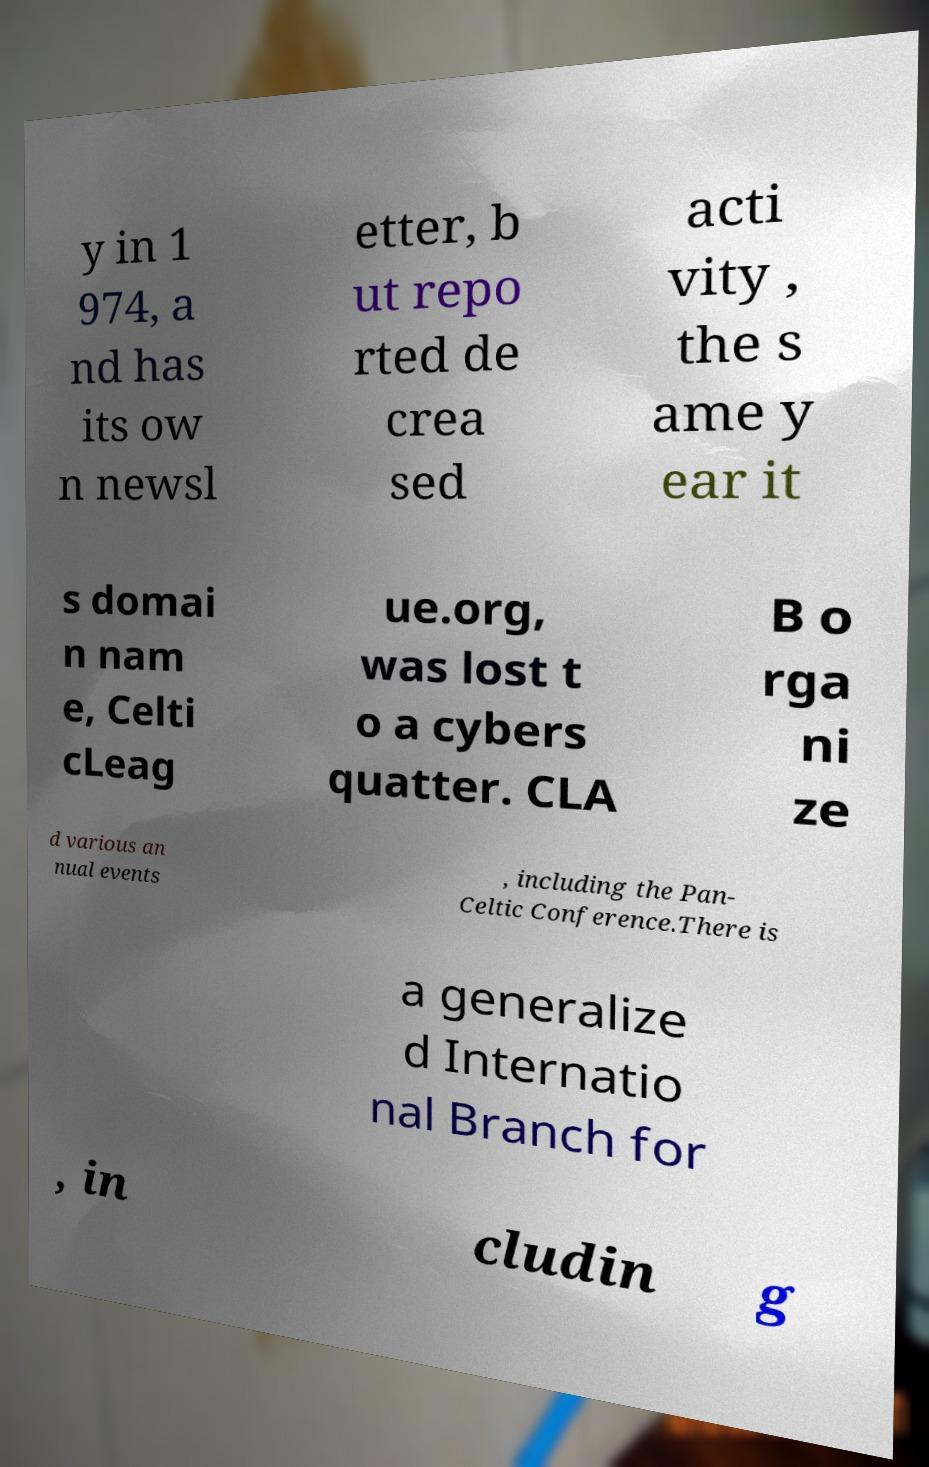For documentation purposes, I need the text within this image transcribed. Could you provide that? y in 1 974, a nd has its ow n newsl etter, b ut repo rted de crea sed acti vity , the s ame y ear it s domai n nam e, Celti cLeag ue.org, was lost t o a cybers quatter. CLA B o rga ni ze d various an nual events , including the Pan- Celtic Conference.There is a generalize d Internatio nal Branch for , in cludin g 